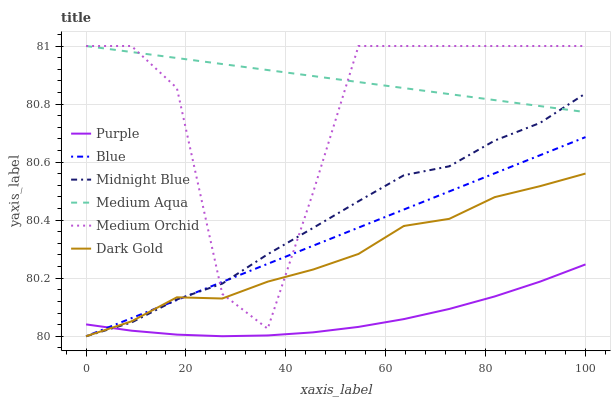Does Purple have the minimum area under the curve?
Answer yes or no. Yes. Does Medium Aqua have the maximum area under the curve?
Answer yes or no. Yes. Does Midnight Blue have the minimum area under the curve?
Answer yes or no. No. Does Midnight Blue have the maximum area under the curve?
Answer yes or no. No. Is Blue the smoothest?
Answer yes or no. Yes. Is Medium Orchid the roughest?
Answer yes or no. Yes. Is Midnight Blue the smoothest?
Answer yes or no. No. Is Midnight Blue the roughest?
Answer yes or no. No. Does Blue have the lowest value?
Answer yes or no. Yes. Does Purple have the lowest value?
Answer yes or no. No. Does Medium Aqua have the highest value?
Answer yes or no. Yes. Does Midnight Blue have the highest value?
Answer yes or no. No. Is Blue less than Medium Aqua?
Answer yes or no. Yes. Is Medium Aqua greater than Purple?
Answer yes or no. Yes. Does Medium Orchid intersect Dark Gold?
Answer yes or no. Yes. Is Medium Orchid less than Dark Gold?
Answer yes or no. No. Is Medium Orchid greater than Dark Gold?
Answer yes or no. No. Does Blue intersect Medium Aqua?
Answer yes or no. No. 